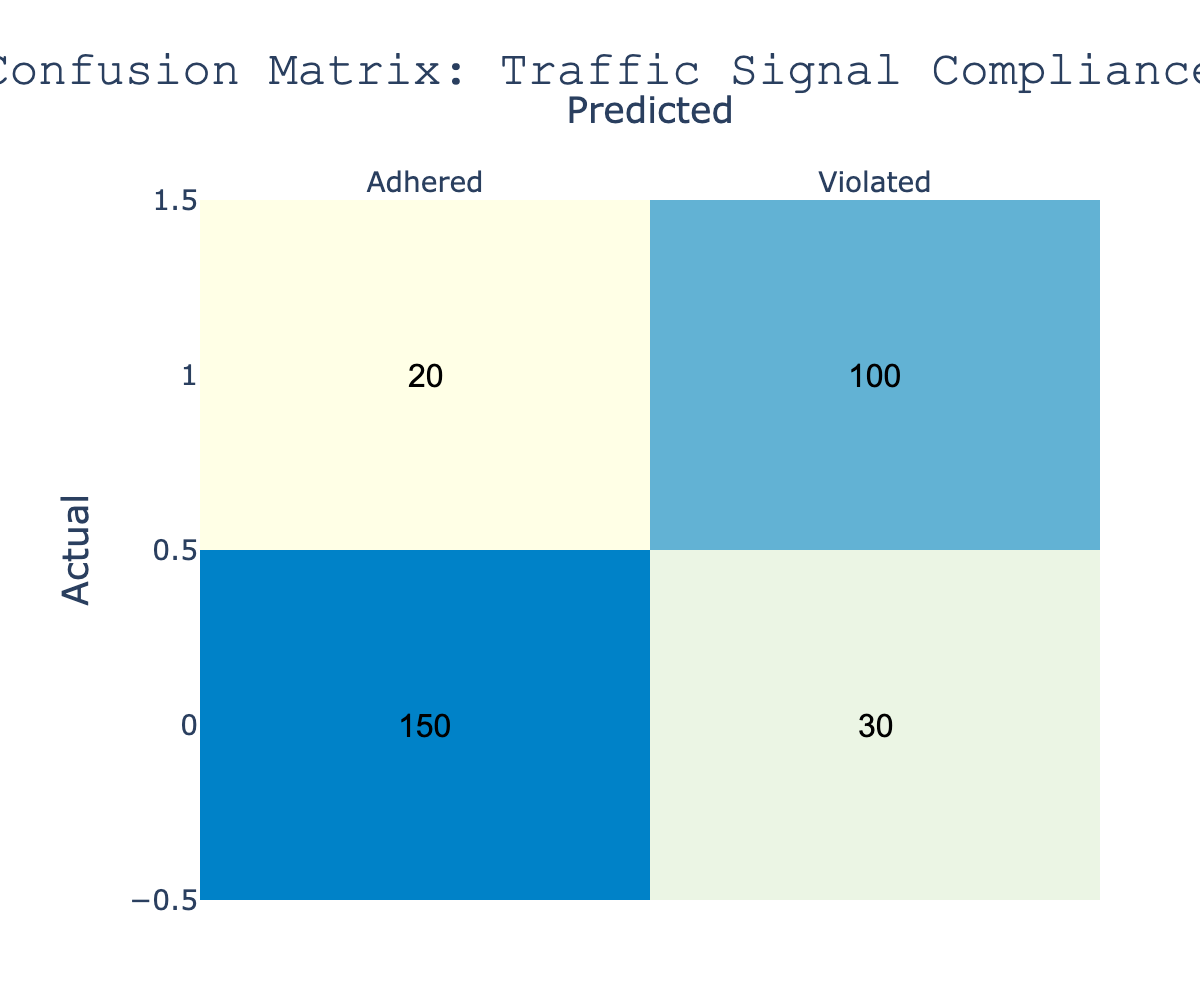What is the total number of adhered signals? To find the total number of adhered signals, we look at the entries in the "Adhered" column. The number of adhered signals in the "Adhered" row is 150, and in the "Violated" row is 20. Thus, the total is 150 + 20 = 170.
Answer: 170 How many violations were correctly predicted? The correctly predicted violations are indicated in the "Violated" row under the "Violated" column. There is a value of 100, showing that this number represents the true violations that were predicted correctly.
Answer: 100 What is the total number of signals predicted as adhered? We need to look at the "Adhered" column and sum the values from both the "Adhered" and "Violated" rows. This equals 150 (true adhered) + 30 (false adhered) = 180.
Answer: 180 Is it true that more signals were adhered than violated in terms of actual signals? The actual adhered signals are 150, while the actual violated signals are 120 (20 + 100). Since 150 > 120, the statement is true.
Answer: Yes What is the accuracy of the prediction model? The accuracy is calculated as the sum of correct predictions divided by the total number of predictions. Correct predictions are 150 (Adhered) + 100 (Violated) = 250, and total predictions are 150 + 30 + 20 + 100 = 300. Thus, the accuracy is 250/300 = 0.8333, or 83.33%.
Answer: 83.33% What is the number of signals that were incorrectly predicted as adhered? To find this, look at the "Violated" row under the "Adhered" column, which indicates the number of violations incorrectly predicted as adhered. This value is 20.
Answer: 20 If we add the number of adhered signals to the number of violated signals, what is the total? We add the total values of the "Adhered" and "Violated" rows. This amounts to 150 (Adhered) + 30 (Violated) + 20 (Violated) + 100 (Violated) = 300.
Answer: 300 What percentage of the predictions were correctly predicted as adhered? The percentage is found by dividing the number of correctly predicted adhered signals by the total predicted adhered signals. We have 150 correctly predicted adhered signals and 180 total predicted as adhered. Thus, the percentage is (150/180) * 100 = 83.33%.
Answer: 83.33% 